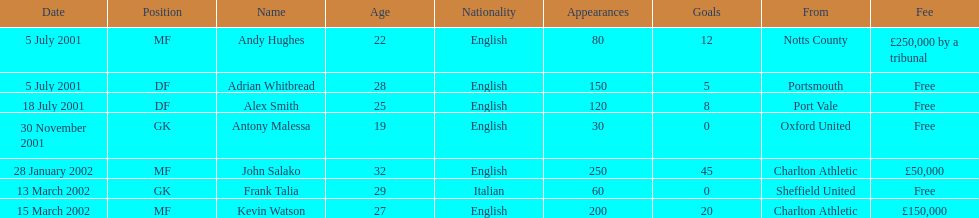Did andy hughes or john salako command the largest fee? Andy Hughes. 